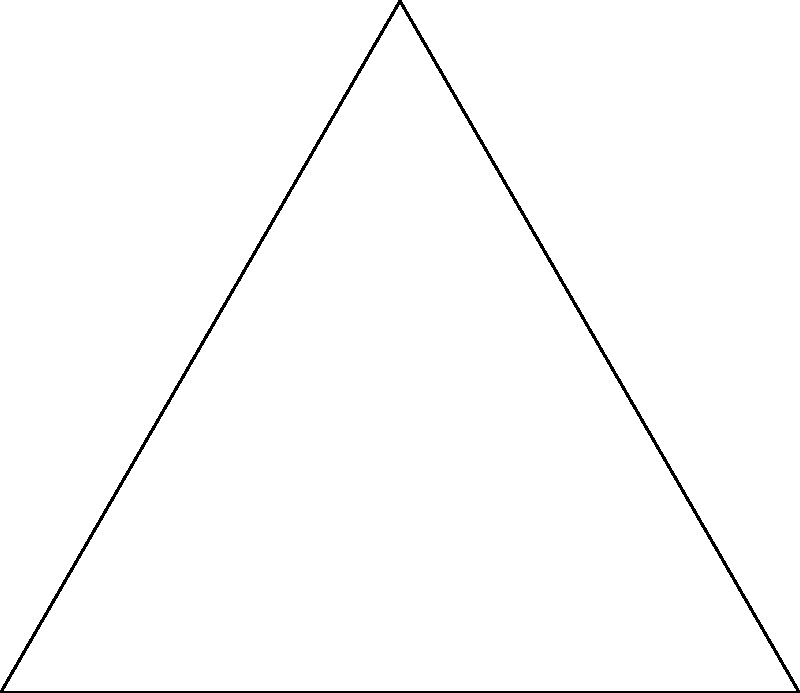In an equilateral triangle ABC with side length 4 units, a circle is inscribed such that it touches all three sides of the triangle. If we consider the harmony between geometric shapes as a reflection of peaceful coexistence, what is the radius of this inscribed circle? Let's approach this step-by-step, reflecting on the balance and symmetry in geometry:

1) In an equilateral triangle, the radius of the inscribed circle (r) is given by the formula:

   $$r = \frac{a}{2\sqrt{3}}$$

   where $a$ is the side length of the triangle.

2) We are given that the side length is 4 units. Let's substitute this into our formula:

   $$r = \frac{4}{2\sqrt{3}}$$

3) Simplify:
   
   $$r = \frac{4}{2\sqrt{3}} = \frac{2}{\sqrt{3}}$$

4) To rationalize the denominator, multiply both numerator and denominator by $\sqrt{3}$:

   $$r = \frac{2}{\sqrt{3}} \cdot \frac{\sqrt{3}}{\sqrt{3}} = \frac{2\sqrt{3}}{3}$$

5) This fraction $\frac{2\sqrt{3}}{3}$ is our final answer. It represents the perfect balance between the triangle and the circle, symbolizing the harmony we seek in peaceful dialogue.
Answer: $\frac{2\sqrt{3}}{3}$ units 